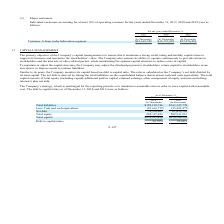According to United Micro Electronics's financial document, What is The primary objective of the Company’s capital management? The primary objective of the Company’s capital management is to ensure that it maintains a strong credit rating and healthy capital ratios to support its business and maximize the stockholders’ value. The Company also ensures its ability to operate continuously to provide returns to stockholders and the interests of other related parties, while maintaining the optimal capital structure to reduce costs of capital.. The document states: "The primary objective of the Company’s capital management is to ensure that it maintains a strong credit rating and healthy capital ratios to support ..." Also, What steps does the company take To maintain or adjust the capital structure? the Company may adjust the dividend payment to stockholders, return capital to stockholders, issue new shares or dispose assets to redeem liabilities.. The document states: "To maintain or adjust the capital structure, the Company may adjust the dividend payment to stockholders, return capital to stockholders, issue new sh..." Also, What is the company's strategy? the Company’s strategy, which is unchanged for the reporting periods, is to maintain a reasonable ratio in order to raise capital with reasonable cost.. The document states: "The Company’s strategy, which is unchanged for the reporting periods, is to maintain a reasonable ratio in order to raise capital with reasonable cost..." Also, can you calculate: What is the increase / (decrease) in the Total liabilities from 2018 to 2019? Based on the calculation: 163,347,778 - 158,199,746, the result is 5148032 (in thousands). This is based on the information: "s) (In Thousands) Total liabilities $158,199,746 $163,347,778 Less: Cash and cash equivalents (83,661,739) (95,492,477) Net debt 74,538,007 67,855,301 Total equi (In Thousands) (In Thousands) Total li..." The key data points involved are: 158,199,746, 163,347,778. Also, can you calculate: What is the increase / (decrease) in the Net debt from 2018 to 2019? Based on the calculation: 67,855,301 - 74,538,007, the result is -6682706 (in thousands). This is based on the information: "sh equivalents (83,661,739) (95,492,477) Net debt 74,538,007 67,855,301 Total equity 204,397,483 202,913,915 Total capital $278,935,490 $270,769,216 Debt to cap nts (83,661,739) (95,492,477) Net debt ..." The key data points involved are: 67,855,301, 74,538,007. Also, can you calculate: What is the percentage increase / (decrease) of Total Capital from 2018 to 2019? To answer this question, I need to perform calculations using the financial data. The calculation is: 270,769,216 / 278,935,490 - 1, which equals -2.93 (percentage). This is based on the information: "4,397,483 202,913,915 Total capital $278,935,490 $270,769,216 Debt to capital ratios 26.72% 25.06% tal equity 204,397,483 202,913,915 Total capital $278,935,490 $270,769,216 Debt to capital ratios 26...." The key data points involved are: 270,769,216, 278,935,490. 